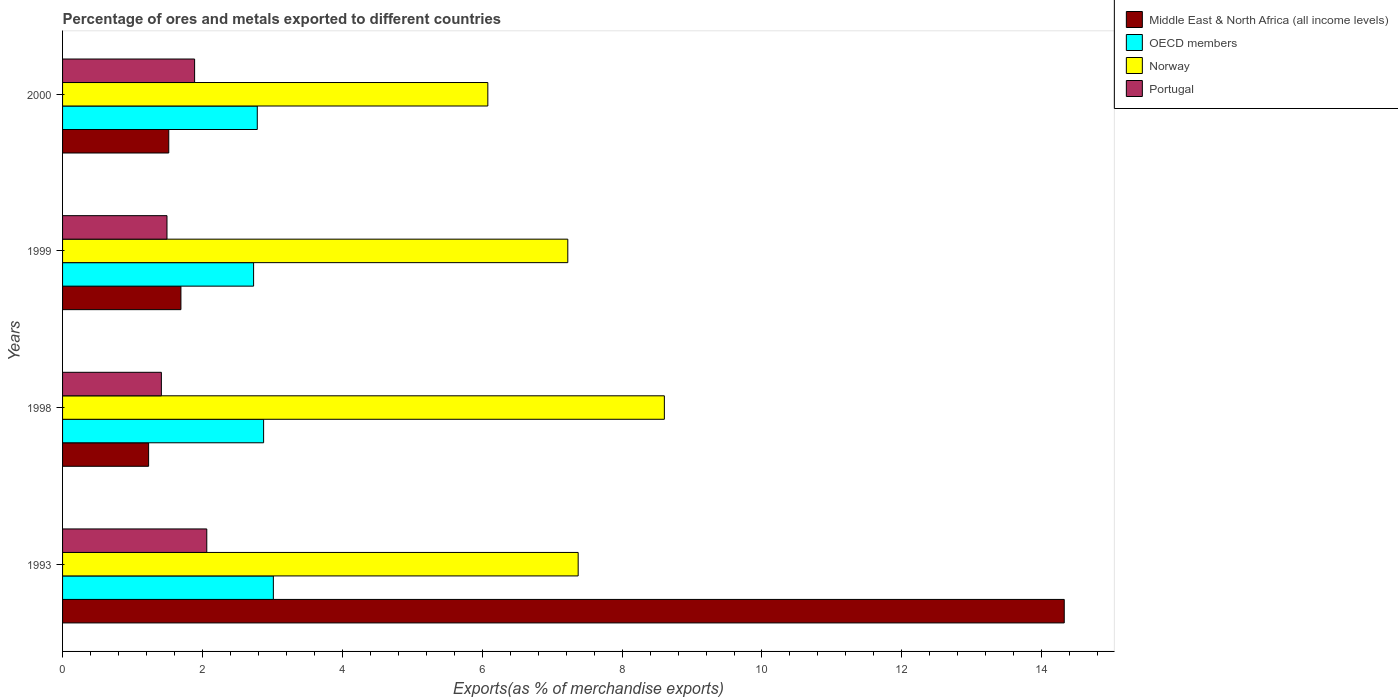How many groups of bars are there?
Give a very brief answer. 4. How many bars are there on the 4th tick from the top?
Your response must be concise. 4. How many bars are there on the 3rd tick from the bottom?
Your answer should be very brief. 4. What is the percentage of exports to different countries in Middle East & North Africa (all income levels) in 1993?
Offer a terse response. 14.32. Across all years, what is the maximum percentage of exports to different countries in Norway?
Your answer should be compact. 8.6. Across all years, what is the minimum percentage of exports to different countries in Portugal?
Make the answer very short. 1.41. What is the total percentage of exports to different countries in Norway in the graph?
Provide a succinct answer. 29.28. What is the difference between the percentage of exports to different countries in Norway in 1998 and that in 2000?
Offer a terse response. 2.52. What is the difference between the percentage of exports to different countries in Middle East & North Africa (all income levels) in 1993 and the percentage of exports to different countries in Portugal in 2000?
Your answer should be compact. 12.43. What is the average percentage of exports to different countries in OECD members per year?
Your answer should be compact. 2.85. In the year 2000, what is the difference between the percentage of exports to different countries in Middle East & North Africa (all income levels) and percentage of exports to different countries in Norway?
Make the answer very short. -4.56. In how many years, is the percentage of exports to different countries in Portugal greater than 2 %?
Provide a succinct answer. 1. What is the ratio of the percentage of exports to different countries in OECD members in 1998 to that in 1999?
Provide a succinct answer. 1.05. Is the percentage of exports to different countries in Portugal in 1998 less than that in 2000?
Give a very brief answer. Yes. What is the difference between the highest and the second highest percentage of exports to different countries in Norway?
Your answer should be very brief. 1.23. What is the difference between the highest and the lowest percentage of exports to different countries in OECD members?
Your answer should be very brief. 0.28. In how many years, is the percentage of exports to different countries in Norway greater than the average percentage of exports to different countries in Norway taken over all years?
Provide a succinct answer. 2. Is the sum of the percentage of exports to different countries in Portugal in 1993 and 2000 greater than the maximum percentage of exports to different countries in Norway across all years?
Ensure brevity in your answer.  No. Is it the case that in every year, the sum of the percentage of exports to different countries in Middle East & North Africa (all income levels) and percentage of exports to different countries in OECD members is greater than the sum of percentage of exports to different countries in Portugal and percentage of exports to different countries in Norway?
Give a very brief answer. No. How many bars are there?
Your answer should be compact. 16. Are all the bars in the graph horizontal?
Make the answer very short. Yes. What is the difference between two consecutive major ticks on the X-axis?
Offer a very short reply. 2. Does the graph contain any zero values?
Keep it short and to the point. No. Where does the legend appear in the graph?
Keep it short and to the point. Top right. What is the title of the graph?
Provide a succinct answer. Percentage of ores and metals exported to different countries. What is the label or title of the X-axis?
Your answer should be compact. Exports(as % of merchandise exports). What is the Exports(as % of merchandise exports) in Middle East & North Africa (all income levels) in 1993?
Provide a succinct answer. 14.32. What is the Exports(as % of merchandise exports) in OECD members in 1993?
Ensure brevity in your answer.  3.01. What is the Exports(as % of merchandise exports) of Norway in 1993?
Provide a succinct answer. 7.37. What is the Exports(as % of merchandise exports) in Portugal in 1993?
Your answer should be compact. 2.06. What is the Exports(as % of merchandise exports) of Middle East & North Africa (all income levels) in 1998?
Offer a very short reply. 1.23. What is the Exports(as % of merchandise exports) in OECD members in 1998?
Your answer should be very brief. 2.87. What is the Exports(as % of merchandise exports) in Norway in 1998?
Give a very brief answer. 8.6. What is the Exports(as % of merchandise exports) in Portugal in 1998?
Give a very brief answer. 1.41. What is the Exports(as % of merchandise exports) in Middle East & North Africa (all income levels) in 1999?
Your answer should be compact. 1.69. What is the Exports(as % of merchandise exports) in OECD members in 1999?
Ensure brevity in your answer.  2.73. What is the Exports(as % of merchandise exports) of Norway in 1999?
Your answer should be compact. 7.22. What is the Exports(as % of merchandise exports) in Portugal in 1999?
Make the answer very short. 1.49. What is the Exports(as % of merchandise exports) of Middle East & North Africa (all income levels) in 2000?
Keep it short and to the point. 1.52. What is the Exports(as % of merchandise exports) in OECD members in 2000?
Your answer should be compact. 2.78. What is the Exports(as % of merchandise exports) in Norway in 2000?
Your answer should be compact. 6.08. What is the Exports(as % of merchandise exports) of Portugal in 2000?
Offer a terse response. 1.89. Across all years, what is the maximum Exports(as % of merchandise exports) in Middle East & North Africa (all income levels)?
Provide a short and direct response. 14.32. Across all years, what is the maximum Exports(as % of merchandise exports) of OECD members?
Keep it short and to the point. 3.01. Across all years, what is the maximum Exports(as % of merchandise exports) in Norway?
Your response must be concise. 8.6. Across all years, what is the maximum Exports(as % of merchandise exports) of Portugal?
Offer a very short reply. 2.06. Across all years, what is the minimum Exports(as % of merchandise exports) of Middle East & North Africa (all income levels)?
Give a very brief answer. 1.23. Across all years, what is the minimum Exports(as % of merchandise exports) of OECD members?
Offer a terse response. 2.73. Across all years, what is the minimum Exports(as % of merchandise exports) of Norway?
Give a very brief answer. 6.08. Across all years, what is the minimum Exports(as % of merchandise exports) of Portugal?
Offer a terse response. 1.41. What is the total Exports(as % of merchandise exports) in Middle East & North Africa (all income levels) in the graph?
Make the answer very short. 18.76. What is the total Exports(as % of merchandise exports) in OECD members in the graph?
Provide a short and direct response. 11.4. What is the total Exports(as % of merchandise exports) in Norway in the graph?
Ensure brevity in your answer.  29.28. What is the total Exports(as % of merchandise exports) in Portugal in the graph?
Make the answer very short. 6.86. What is the difference between the Exports(as % of merchandise exports) in Middle East & North Africa (all income levels) in 1993 and that in 1998?
Give a very brief answer. 13.09. What is the difference between the Exports(as % of merchandise exports) in OECD members in 1993 and that in 1998?
Make the answer very short. 0.14. What is the difference between the Exports(as % of merchandise exports) of Norway in 1993 and that in 1998?
Your answer should be very brief. -1.23. What is the difference between the Exports(as % of merchandise exports) of Portugal in 1993 and that in 1998?
Give a very brief answer. 0.65. What is the difference between the Exports(as % of merchandise exports) in Middle East & North Africa (all income levels) in 1993 and that in 1999?
Keep it short and to the point. 12.63. What is the difference between the Exports(as % of merchandise exports) of OECD members in 1993 and that in 1999?
Your response must be concise. 0.28. What is the difference between the Exports(as % of merchandise exports) in Norway in 1993 and that in 1999?
Your response must be concise. 0.15. What is the difference between the Exports(as % of merchandise exports) in Portugal in 1993 and that in 1999?
Provide a succinct answer. 0.57. What is the difference between the Exports(as % of merchandise exports) of Middle East & North Africa (all income levels) in 1993 and that in 2000?
Keep it short and to the point. 12.8. What is the difference between the Exports(as % of merchandise exports) in OECD members in 1993 and that in 2000?
Offer a terse response. 0.23. What is the difference between the Exports(as % of merchandise exports) in Norway in 1993 and that in 2000?
Give a very brief answer. 1.29. What is the difference between the Exports(as % of merchandise exports) in Portugal in 1993 and that in 2000?
Your response must be concise. 0.17. What is the difference between the Exports(as % of merchandise exports) of Middle East & North Africa (all income levels) in 1998 and that in 1999?
Your response must be concise. -0.46. What is the difference between the Exports(as % of merchandise exports) of OECD members in 1998 and that in 1999?
Ensure brevity in your answer.  0.14. What is the difference between the Exports(as % of merchandise exports) in Norway in 1998 and that in 1999?
Ensure brevity in your answer.  1.38. What is the difference between the Exports(as % of merchandise exports) in Portugal in 1998 and that in 1999?
Make the answer very short. -0.08. What is the difference between the Exports(as % of merchandise exports) in Middle East & North Africa (all income levels) in 1998 and that in 2000?
Your answer should be compact. -0.29. What is the difference between the Exports(as % of merchandise exports) of OECD members in 1998 and that in 2000?
Offer a very short reply. 0.09. What is the difference between the Exports(as % of merchandise exports) in Norway in 1998 and that in 2000?
Your answer should be very brief. 2.52. What is the difference between the Exports(as % of merchandise exports) of Portugal in 1998 and that in 2000?
Ensure brevity in your answer.  -0.48. What is the difference between the Exports(as % of merchandise exports) of Middle East & North Africa (all income levels) in 1999 and that in 2000?
Offer a terse response. 0.17. What is the difference between the Exports(as % of merchandise exports) in OECD members in 1999 and that in 2000?
Make the answer very short. -0.05. What is the difference between the Exports(as % of merchandise exports) in Norway in 1999 and that in 2000?
Your response must be concise. 1.14. What is the difference between the Exports(as % of merchandise exports) in Portugal in 1999 and that in 2000?
Provide a succinct answer. -0.39. What is the difference between the Exports(as % of merchandise exports) of Middle East & North Africa (all income levels) in 1993 and the Exports(as % of merchandise exports) of OECD members in 1998?
Provide a succinct answer. 11.45. What is the difference between the Exports(as % of merchandise exports) in Middle East & North Africa (all income levels) in 1993 and the Exports(as % of merchandise exports) in Norway in 1998?
Offer a terse response. 5.72. What is the difference between the Exports(as % of merchandise exports) of Middle East & North Africa (all income levels) in 1993 and the Exports(as % of merchandise exports) of Portugal in 1998?
Offer a very short reply. 12.91. What is the difference between the Exports(as % of merchandise exports) in OECD members in 1993 and the Exports(as % of merchandise exports) in Norway in 1998?
Your response must be concise. -5.59. What is the difference between the Exports(as % of merchandise exports) of OECD members in 1993 and the Exports(as % of merchandise exports) of Portugal in 1998?
Offer a terse response. 1.6. What is the difference between the Exports(as % of merchandise exports) of Norway in 1993 and the Exports(as % of merchandise exports) of Portugal in 1998?
Provide a short and direct response. 5.96. What is the difference between the Exports(as % of merchandise exports) in Middle East & North Africa (all income levels) in 1993 and the Exports(as % of merchandise exports) in OECD members in 1999?
Give a very brief answer. 11.59. What is the difference between the Exports(as % of merchandise exports) of Middle East & North Africa (all income levels) in 1993 and the Exports(as % of merchandise exports) of Norway in 1999?
Provide a short and direct response. 7.1. What is the difference between the Exports(as % of merchandise exports) in Middle East & North Africa (all income levels) in 1993 and the Exports(as % of merchandise exports) in Portugal in 1999?
Keep it short and to the point. 12.83. What is the difference between the Exports(as % of merchandise exports) in OECD members in 1993 and the Exports(as % of merchandise exports) in Norway in 1999?
Your answer should be very brief. -4.21. What is the difference between the Exports(as % of merchandise exports) of OECD members in 1993 and the Exports(as % of merchandise exports) of Portugal in 1999?
Ensure brevity in your answer.  1.52. What is the difference between the Exports(as % of merchandise exports) in Norway in 1993 and the Exports(as % of merchandise exports) in Portugal in 1999?
Offer a very short reply. 5.88. What is the difference between the Exports(as % of merchandise exports) in Middle East & North Africa (all income levels) in 1993 and the Exports(as % of merchandise exports) in OECD members in 2000?
Your response must be concise. 11.54. What is the difference between the Exports(as % of merchandise exports) of Middle East & North Africa (all income levels) in 1993 and the Exports(as % of merchandise exports) of Norway in 2000?
Ensure brevity in your answer.  8.24. What is the difference between the Exports(as % of merchandise exports) of Middle East & North Africa (all income levels) in 1993 and the Exports(as % of merchandise exports) of Portugal in 2000?
Your answer should be very brief. 12.43. What is the difference between the Exports(as % of merchandise exports) in OECD members in 1993 and the Exports(as % of merchandise exports) in Norway in 2000?
Provide a short and direct response. -3.07. What is the difference between the Exports(as % of merchandise exports) in OECD members in 1993 and the Exports(as % of merchandise exports) in Portugal in 2000?
Give a very brief answer. 1.13. What is the difference between the Exports(as % of merchandise exports) of Norway in 1993 and the Exports(as % of merchandise exports) of Portugal in 2000?
Make the answer very short. 5.48. What is the difference between the Exports(as % of merchandise exports) of Middle East & North Africa (all income levels) in 1998 and the Exports(as % of merchandise exports) of OECD members in 1999?
Provide a short and direct response. -1.5. What is the difference between the Exports(as % of merchandise exports) in Middle East & North Africa (all income levels) in 1998 and the Exports(as % of merchandise exports) in Norway in 1999?
Provide a short and direct response. -5.99. What is the difference between the Exports(as % of merchandise exports) of Middle East & North Africa (all income levels) in 1998 and the Exports(as % of merchandise exports) of Portugal in 1999?
Make the answer very short. -0.26. What is the difference between the Exports(as % of merchandise exports) of OECD members in 1998 and the Exports(as % of merchandise exports) of Norway in 1999?
Provide a short and direct response. -4.35. What is the difference between the Exports(as % of merchandise exports) in OECD members in 1998 and the Exports(as % of merchandise exports) in Portugal in 1999?
Your response must be concise. 1.38. What is the difference between the Exports(as % of merchandise exports) in Norway in 1998 and the Exports(as % of merchandise exports) in Portugal in 1999?
Provide a short and direct response. 7.11. What is the difference between the Exports(as % of merchandise exports) of Middle East & North Africa (all income levels) in 1998 and the Exports(as % of merchandise exports) of OECD members in 2000?
Make the answer very short. -1.55. What is the difference between the Exports(as % of merchandise exports) of Middle East & North Africa (all income levels) in 1998 and the Exports(as % of merchandise exports) of Norway in 2000?
Your answer should be compact. -4.85. What is the difference between the Exports(as % of merchandise exports) of Middle East & North Africa (all income levels) in 1998 and the Exports(as % of merchandise exports) of Portugal in 2000?
Your answer should be very brief. -0.66. What is the difference between the Exports(as % of merchandise exports) in OECD members in 1998 and the Exports(as % of merchandise exports) in Norway in 2000?
Provide a short and direct response. -3.21. What is the difference between the Exports(as % of merchandise exports) of OECD members in 1998 and the Exports(as % of merchandise exports) of Portugal in 2000?
Your answer should be very brief. 0.99. What is the difference between the Exports(as % of merchandise exports) of Norway in 1998 and the Exports(as % of merchandise exports) of Portugal in 2000?
Keep it short and to the point. 6.72. What is the difference between the Exports(as % of merchandise exports) of Middle East & North Africa (all income levels) in 1999 and the Exports(as % of merchandise exports) of OECD members in 2000?
Provide a succinct answer. -1.09. What is the difference between the Exports(as % of merchandise exports) in Middle East & North Africa (all income levels) in 1999 and the Exports(as % of merchandise exports) in Norway in 2000?
Your answer should be very brief. -4.39. What is the difference between the Exports(as % of merchandise exports) of Middle East & North Africa (all income levels) in 1999 and the Exports(as % of merchandise exports) of Portugal in 2000?
Offer a very short reply. -0.2. What is the difference between the Exports(as % of merchandise exports) in OECD members in 1999 and the Exports(as % of merchandise exports) in Norway in 2000?
Give a very brief answer. -3.35. What is the difference between the Exports(as % of merchandise exports) in OECD members in 1999 and the Exports(as % of merchandise exports) in Portugal in 2000?
Offer a terse response. 0.84. What is the difference between the Exports(as % of merchandise exports) in Norway in 1999 and the Exports(as % of merchandise exports) in Portugal in 2000?
Provide a succinct answer. 5.34. What is the average Exports(as % of merchandise exports) in Middle East & North Africa (all income levels) per year?
Make the answer very short. 4.69. What is the average Exports(as % of merchandise exports) in OECD members per year?
Provide a succinct answer. 2.85. What is the average Exports(as % of merchandise exports) in Norway per year?
Provide a short and direct response. 7.32. What is the average Exports(as % of merchandise exports) of Portugal per year?
Provide a succinct answer. 1.71. In the year 1993, what is the difference between the Exports(as % of merchandise exports) of Middle East & North Africa (all income levels) and Exports(as % of merchandise exports) of OECD members?
Give a very brief answer. 11.31. In the year 1993, what is the difference between the Exports(as % of merchandise exports) of Middle East & North Africa (all income levels) and Exports(as % of merchandise exports) of Norway?
Your answer should be compact. 6.95. In the year 1993, what is the difference between the Exports(as % of merchandise exports) of Middle East & North Africa (all income levels) and Exports(as % of merchandise exports) of Portugal?
Keep it short and to the point. 12.26. In the year 1993, what is the difference between the Exports(as % of merchandise exports) of OECD members and Exports(as % of merchandise exports) of Norway?
Offer a terse response. -4.36. In the year 1993, what is the difference between the Exports(as % of merchandise exports) of OECD members and Exports(as % of merchandise exports) of Portugal?
Offer a very short reply. 0.95. In the year 1993, what is the difference between the Exports(as % of merchandise exports) of Norway and Exports(as % of merchandise exports) of Portugal?
Keep it short and to the point. 5.31. In the year 1998, what is the difference between the Exports(as % of merchandise exports) in Middle East & North Africa (all income levels) and Exports(as % of merchandise exports) in OECD members?
Your response must be concise. -1.64. In the year 1998, what is the difference between the Exports(as % of merchandise exports) in Middle East & North Africa (all income levels) and Exports(as % of merchandise exports) in Norway?
Offer a very short reply. -7.37. In the year 1998, what is the difference between the Exports(as % of merchandise exports) in Middle East & North Africa (all income levels) and Exports(as % of merchandise exports) in Portugal?
Ensure brevity in your answer.  -0.18. In the year 1998, what is the difference between the Exports(as % of merchandise exports) in OECD members and Exports(as % of merchandise exports) in Norway?
Offer a terse response. -5.73. In the year 1998, what is the difference between the Exports(as % of merchandise exports) in OECD members and Exports(as % of merchandise exports) in Portugal?
Keep it short and to the point. 1.46. In the year 1998, what is the difference between the Exports(as % of merchandise exports) in Norway and Exports(as % of merchandise exports) in Portugal?
Provide a succinct answer. 7.19. In the year 1999, what is the difference between the Exports(as % of merchandise exports) of Middle East & North Africa (all income levels) and Exports(as % of merchandise exports) of OECD members?
Offer a very short reply. -1.04. In the year 1999, what is the difference between the Exports(as % of merchandise exports) in Middle East & North Africa (all income levels) and Exports(as % of merchandise exports) in Norway?
Offer a very short reply. -5.53. In the year 1999, what is the difference between the Exports(as % of merchandise exports) of Middle East & North Africa (all income levels) and Exports(as % of merchandise exports) of Portugal?
Ensure brevity in your answer.  0.2. In the year 1999, what is the difference between the Exports(as % of merchandise exports) in OECD members and Exports(as % of merchandise exports) in Norway?
Give a very brief answer. -4.49. In the year 1999, what is the difference between the Exports(as % of merchandise exports) in OECD members and Exports(as % of merchandise exports) in Portugal?
Your answer should be very brief. 1.24. In the year 1999, what is the difference between the Exports(as % of merchandise exports) of Norway and Exports(as % of merchandise exports) of Portugal?
Provide a short and direct response. 5.73. In the year 2000, what is the difference between the Exports(as % of merchandise exports) in Middle East & North Africa (all income levels) and Exports(as % of merchandise exports) in OECD members?
Your answer should be very brief. -1.27. In the year 2000, what is the difference between the Exports(as % of merchandise exports) of Middle East & North Africa (all income levels) and Exports(as % of merchandise exports) of Norway?
Your response must be concise. -4.56. In the year 2000, what is the difference between the Exports(as % of merchandise exports) of Middle East & North Africa (all income levels) and Exports(as % of merchandise exports) of Portugal?
Make the answer very short. -0.37. In the year 2000, what is the difference between the Exports(as % of merchandise exports) of OECD members and Exports(as % of merchandise exports) of Norway?
Your answer should be very brief. -3.3. In the year 2000, what is the difference between the Exports(as % of merchandise exports) in OECD members and Exports(as % of merchandise exports) in Portugal?
Ensure brevity in your answer.  0.9. In the year 2000, what is the difference between the Exports(as % of merchandise exports) of Norway and Exports(as % of merchandise exports) of Portugal?
Your response must be concise. 4.19. What is the ratio of the Exports(as % of merchandise exports) of Middle East & North Africa (all income levels) in 1993 to that in 1998?
Your answer should be very brief. 11.64. What is the ratio of the Exports(as % of merchandise exports) of OECD members in 1993 to that in 1998?
Provide a succinct answer. 1.05. What is the ratio of the Exports(as % of merchandise exports) in Norway in 1993 to that in 1998?
Your response must be concise. 0.86. What is the ratio of the Exports(as % of merchandise exports) of Portugal in 1993 to that in 1998?
Provide a short and direct response. 1.46. What is the ratio of the Exports(as % of merchandise exports) of Middle East & North Africa (all income levels) in 1993 to that in 1999?
Give a very brief answer. 8.46. What is the ratio of the Exports(as % of merchandise exports) in OECD members in 1993 to that in 1999?
Provide a short and direct response. 1.1. What is the ratio of the Exports(as % of merchandise exports) in Norway in 1993 to that in 1999?
Provide a succinct answer. 1.02. What is the ratio of the Exports(as % of merchandise exports) of Portugal in 1993 to that in 1999?
Make the answer very short. 1.38. What is the ratio of the Exports(as % of merchandise exports) of Middle East & North Africa (all income levels) in 1993 to that in 2000?
Give a very brief answer. 9.43. What is the ratio of the Exports(as % of merchandise exports) of OECD members in 1993 to that in 2000?
Offer a terse response. 1.08. What is the ratio of the Exports(as % of merchandise exports) in Norway in 1993 to that in 2000?
Keep it short and to the point. 1.21. What is the ratio of the Exports(as % of merchandise exports) in Portugal in 1993 to that in 2000?
Your answer should be very brief. 1.09. What is the ratio of the Exports(as % of merchandise exports) of Middle East & North Africa (all income levels) in 1998 to that in 1999?
Keep it short and to the point. 0.73. What is the ratio of the Exports(as % of merchandise exports) of OECD members in 1998 to that in 1999?
Your answer should be compact. 1.05. What is the ratio of the Exports(as % of merchandise exports) in Norway in 1998 to that in 1999?
Give a very brief answer. 1.19. What is the ratio of the Exports(as % of merchandise exports) of Portugal in 1998 to that in 1999?
Make the answer very short. 0.95. What is the ratio of the Exports(as % of merchandise exports) in Middle East & North Africa (all income levels) in 1998 to that in 2000?
Make the answer very short. 0.81. What is the ratio of the Exports(as % of merchandise exports) of OECD members in 1998 to that in 2000?
Provide a succinct answer. 1.03. What is the ratio of the Exports(as % of merchandise exports) in Norway in 1998 to that in 2000?
Provide a succinct answer. 1.42. What is the ratio of the Exports(as % of merchandise exports) in Portugal in 1998 to that in 2000?
Your answer should be compact. 0.75. What is the ratio of the Exports(as % of merchandise exports) in Middle East & North Africa (all income levels) in 1999 to that in 2000?
Your response must be concise. 1.11. What is the ratio of the Exports(as % of merchandise exports) in OECD members in 1999 to that in 2000?
Your answer should be very brief. 0.98. What is the ratio of the Exports(as % of merchandise exports) of Norway in 1999 to that in 2000?
Offer a terse response. 1.19. What is the ratio of the Exports(as % of merchandise exports) of Portugal in 1999 to that in 2000?
Your response must be concise. 0.79. What is the difference between the highest and the second highest Exports(as % of merchandise exports) in Middle East & North Africa (all income levels)?
Keep it short and to the point. 12.63. What is the difference between the highest and the second highest Exports(as % of merchandise exports) in OECD members?
Give a very brief answer. 0.14. What is the difference between the highest and the second highest Exports(as % of merchandise exports) of Norway?
Provide a succinct answer. 1.23. What is the difference between the highest and the second highest Exports(as % of merchandise exports) in Portugal?
Ensure brevity in your answer.  0.17. What is the difference between the highest and the lowest Exports(as % of merchandise exports) in Middle East & North Africa (all income levels)?
Ensure brevity in your answer.  13.09. What is the difference between the highest and the lowest Exports(as % of merchandise exports) in OECD members?
Offer a terse response. 0.28. What is the difference between the highest and the lowest Exports(as % of merchandise exports) in Norway?
Keep it short and to the point. 2.52. What is the difference between the highest and the lowest Exports(as % of merchandise exports) of Portugal?
Your answer should be compact. 0.65. 